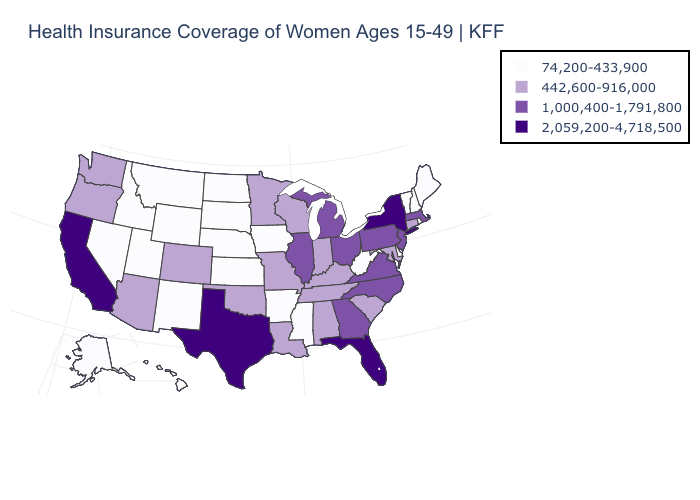What is the value of California?
Be succinct. 2,059,200-4,718,500. What is the value of Alaska?
Quick response, please. 74,200-433,900. Does the map have missing data?
Concise answer only. No. Name the states that have a value in the range 2,059,200-4,718,500?
Give a very brief answer. California, Florida, New York, Texas. Name the states that have a value in the range 1,000,400-1,791,800?
Short answer required. Georgia, Illinois, Massachusetts, Michigan, New Jersey, North Carolina, Ohio, Pennsylvania, Virginia. Does the first symbol in the legend represent the smallest category?
Answer briefly. Yes. Does the first symbol in the legend represent the smallest category?
Short answer required. Yes. What is the value of Minnesota?
Write a very short answer. 442,600-916,000. Does Arkansas have a lower value than Virginia?
Keep it brief. Yes. Which states have the highest value in the USA?
Concise answer only. California, Florida, New York, Texas. What is the value of Washington?
Quick response, please. 442,600-916,000. Which states hav the highest value in the MidWest?
Short answer required. Illinois, Michigan, Ohio. Does Louisiana have the same value as Wyoming?
Short answer required. No. Does Illinois have the lowest value in the MidWest?
Keep it brief. No. 